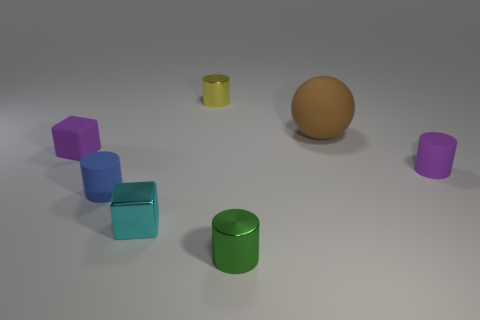What is the color of the matte cylinder in front of the purple object on the right side of the metal cylinder in front of the large rubber thing? blue 